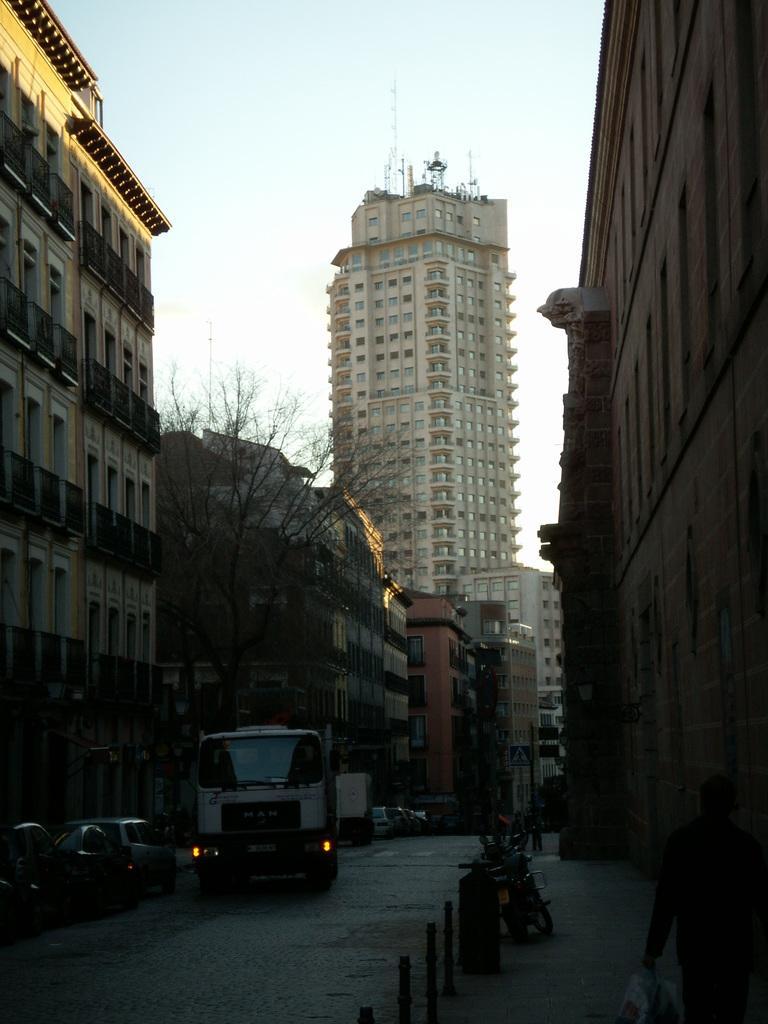In one or two sentences, can you explain what this image depicts? In this picture we can observe a road on which a vehicle was moving. There are some cars moving beside this vehicle. We can observe some poles and a bike parked in the right side. There is a tree. We can observe buildings here. In the background there is a sky. 